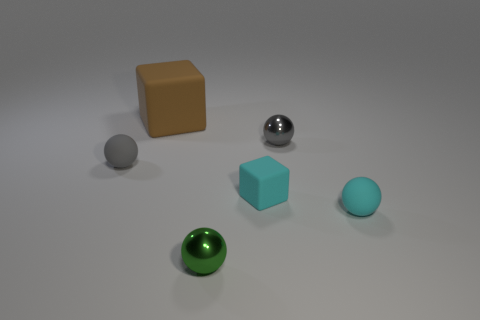Subtract all cyan balls. How many balls are left? 3 Subtract all cyan balls. How many balls are left? 3 Add 2 large matte things. How many objects exist? 8 Subtract all blue spheres. Subtract all purple cylinders. How many spheres are left? 4 Subtract all spheres. How many objects are left? 2 Subtract all gray shiny things. Subtract all gray things. How many objects are left? 3 Add 1 small cubes. How many small cubes are left? 2 Add 1 brown cylinders. How many brown cylinders exist? 1 Subtract 0 purple blocks. How many objects are left? 6 